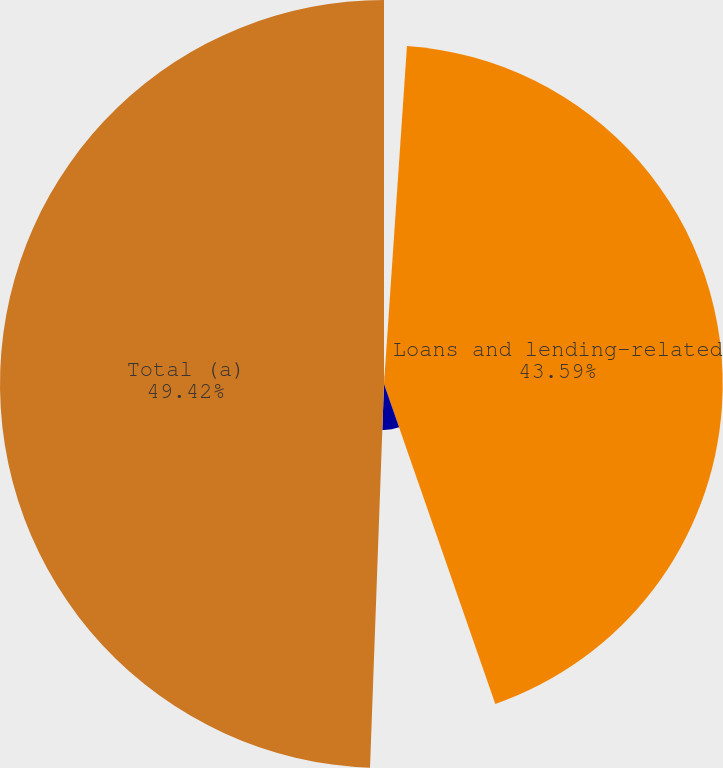Convert chart. <chart><loc_0><loc_0><loc_500><loc_500><pie_chart><fcel>(in millions)<fcel>Loans and lending-related<fcel>Derivative receivables<fcel>Total (a)<nl><fcel>1.08%<fcel>43.59%<fcel>5.91%<fcel>49.42%<nl></chart> 